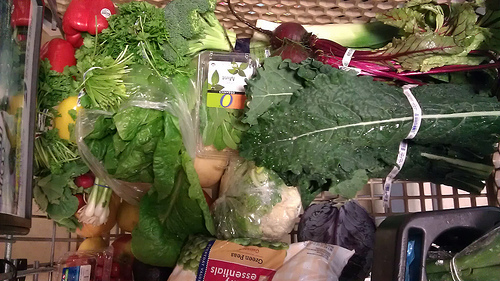<image>
Can you confirm if the cauliflower is under the leaf? No. The cauliflower is not positioned under the leaf. The vertical relationship between these objects is different. 